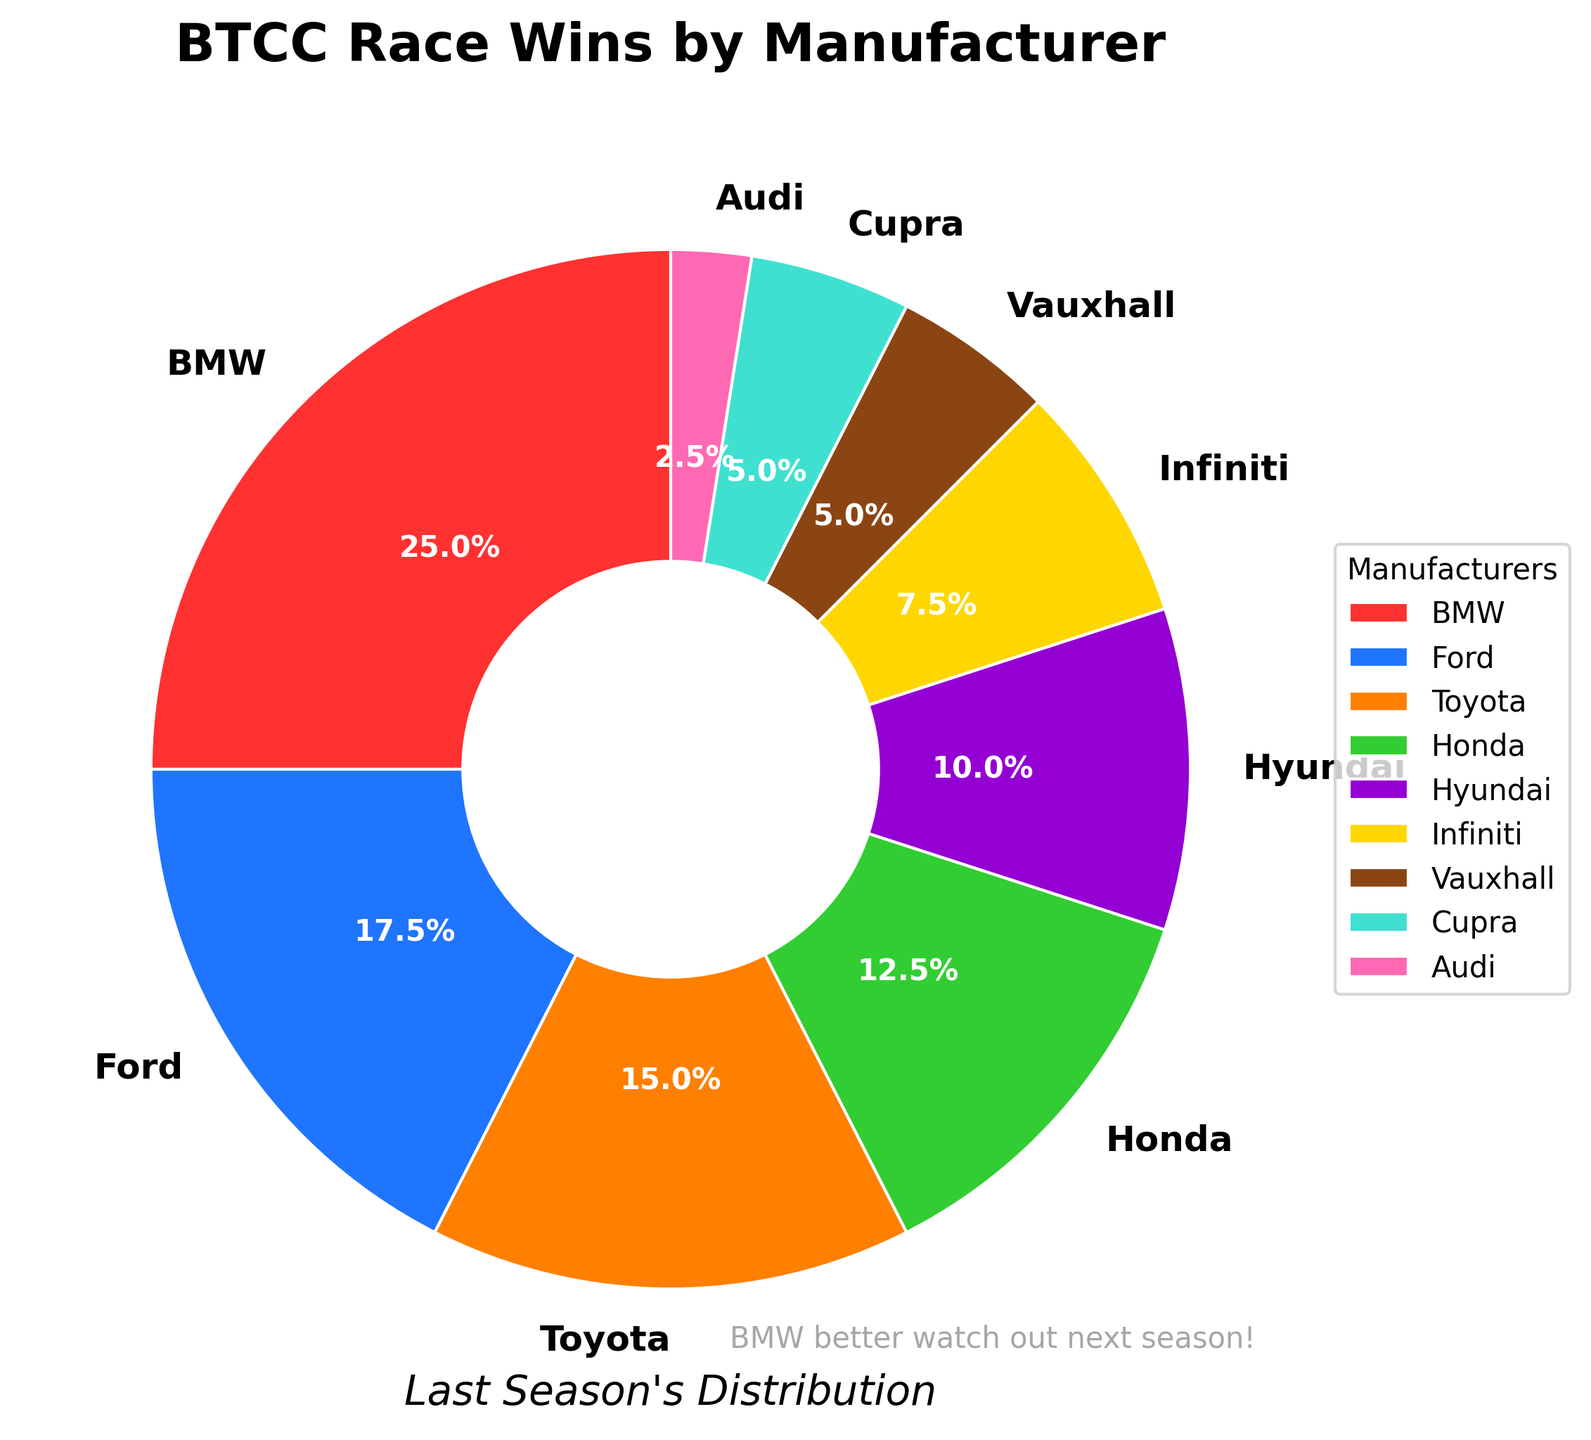Which manufacturer won the most races? BMW is the manufacturer with the largest segment in the pie chart, and BMW won 10 races.
Answer: BMW How many total races did the top 3 manufacturers win? Sum the race wins of BMW (10), Ford (7), and Toyota (6). So, 10 + 7 + 6 = 23.
Answer: 23 Which manufacturers are tied for the least number of wins? The pie chart segments for Vauxhall and Cupra are the same size, each showing 2 wins.
Answer: Vauxhall and Cupra How many more races did BMW win compared to Honda? Subtract Honda's wins (5) from BMW's wins (10). So, 10 - 5 = 5.
Answer: 5 What percentage of the total race wins did Hyundai achieve? By looking at the pie chart, Hyundai's segment is labeled as 4 wins out of a total of 40 wins. Calculate the percentage: (4 / 40) * 100 = 10%.
Answer: 10% If we combined the race wins of Infiniti and Audi, how many wins would that be? Add Infiniti's wins (3) to Audi's wins (1). So, 3 + 1 = 4.
Answer: 4 Does Toyota have more race wins than Hyundai? Compare Toyota's segment (6 wins) to Hyundai's segment (4 wins). Since 6 > 4, Toyota has more wins.
Answer: Yes What visual effect is used to highlight the differences between manufacturer wins? The pie chart uses colors and segment sizes to visually differentiate the race wins among manufacturers. Each manufacturer has a unique color, and the size of each segment represents the number of wins.
Answer: Colors and segment sizes How many total races did the bottom four manufacturers win? Sum the race wins of Infiniti (3), Vauxhall (2), Cupra (2), and Audi (1). So, 3 + 2 + 2 + 1 = 8.
Answer: 8 Which manufacturer has a wedge in the pie chart with a purple color? By looking at the pie chart's legend, the segment with a purple color represents Toyota.
Answer: Toyota 